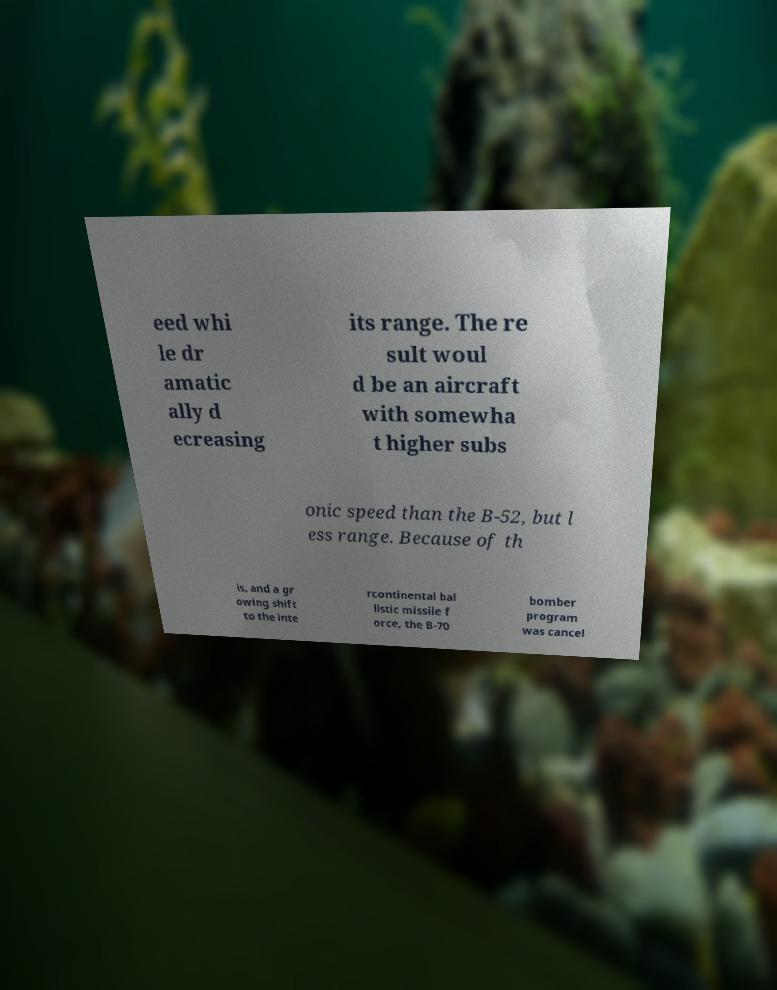What messages or text are displayed in this image? I need them in a readable, typed format. eed whi le dr amatic ally d ecreasing its range. The re sult woul d be an aircraft with somewha t higher subs onic speed than the B-52, but l ess range. Because of th is, and a gr owing shift to the inte rcontinental bal listic missile f orce, the B-70 bomber program was cancel 